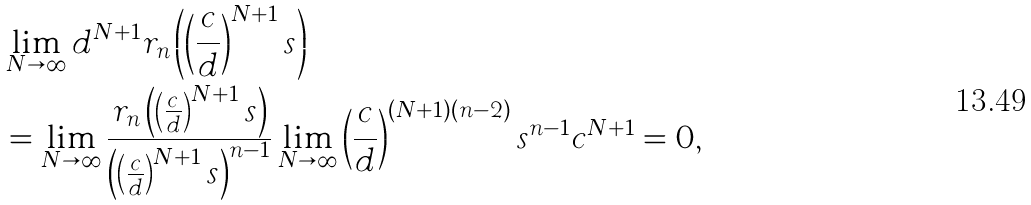<formula> <loc_0><loc_0><loc_500><loc_500>& \lim _ { N \to \infty } d ^ { N + 1 } r _ { n } \left ( \left ( \frac { c } { d } \right ) ^ { N + 1 } s \right ) \\ & = \lim _ { N \to \infty } \frac { r _ { n } \left ( \left ( \frac { c } { d } \right ) ^ { N + 1 } s \right ) } { \left ( \left ( \frac { c } { d } \right ) ^ { N + 1 } s \right ) ^ { n - 1 } } \lim _ { N \to \infty } \left ( \frac { c } { d } \right ) ^ { ( N + 1 ) ( n - 2 ) } s ^ { n - 1 } c ^ { N + 1 } = 0 ,</formula> 